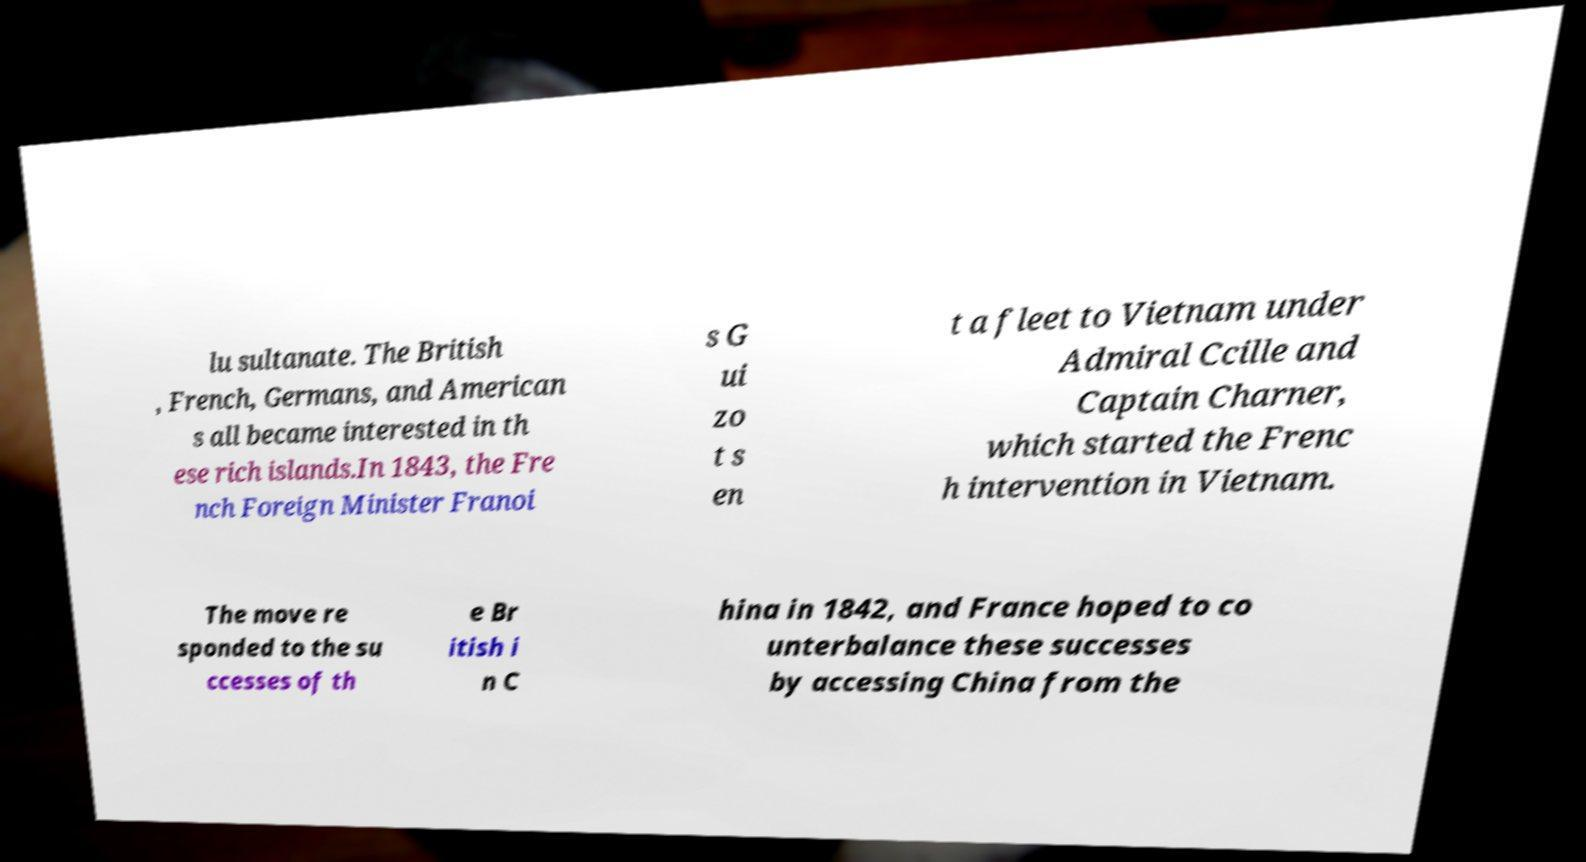What messages or text are displayed in this image? I need them in a readable, typed format. lu sultanate. The British , French, Germans, and American s all became interested in th ese rich islands.In 1843, the Fre nch Foreign Minister Franoi s G ui zo t s en t a fleet to Vietnam under Admiral Ccille and Captain Charner, which started the Frenc h intervention in Vietnam. The move re sponded to the su ccesses of th e Br itish i n C hina in 1842, and France hoped to co unterbalance these successes by accessing China from the 